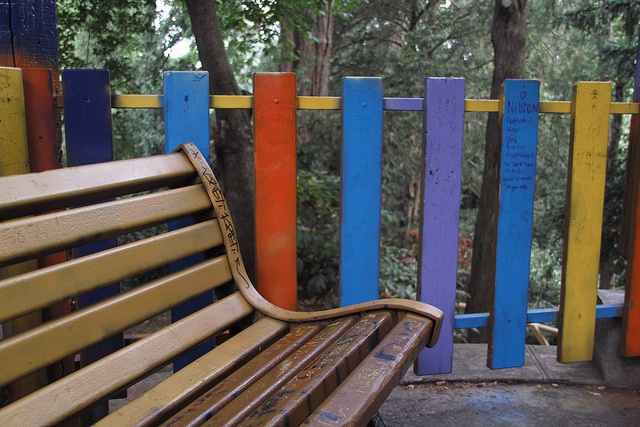Describe the objects in this image and their specific colors. I can see a bench in black, brown, tan, and darkgray tones in this image. 